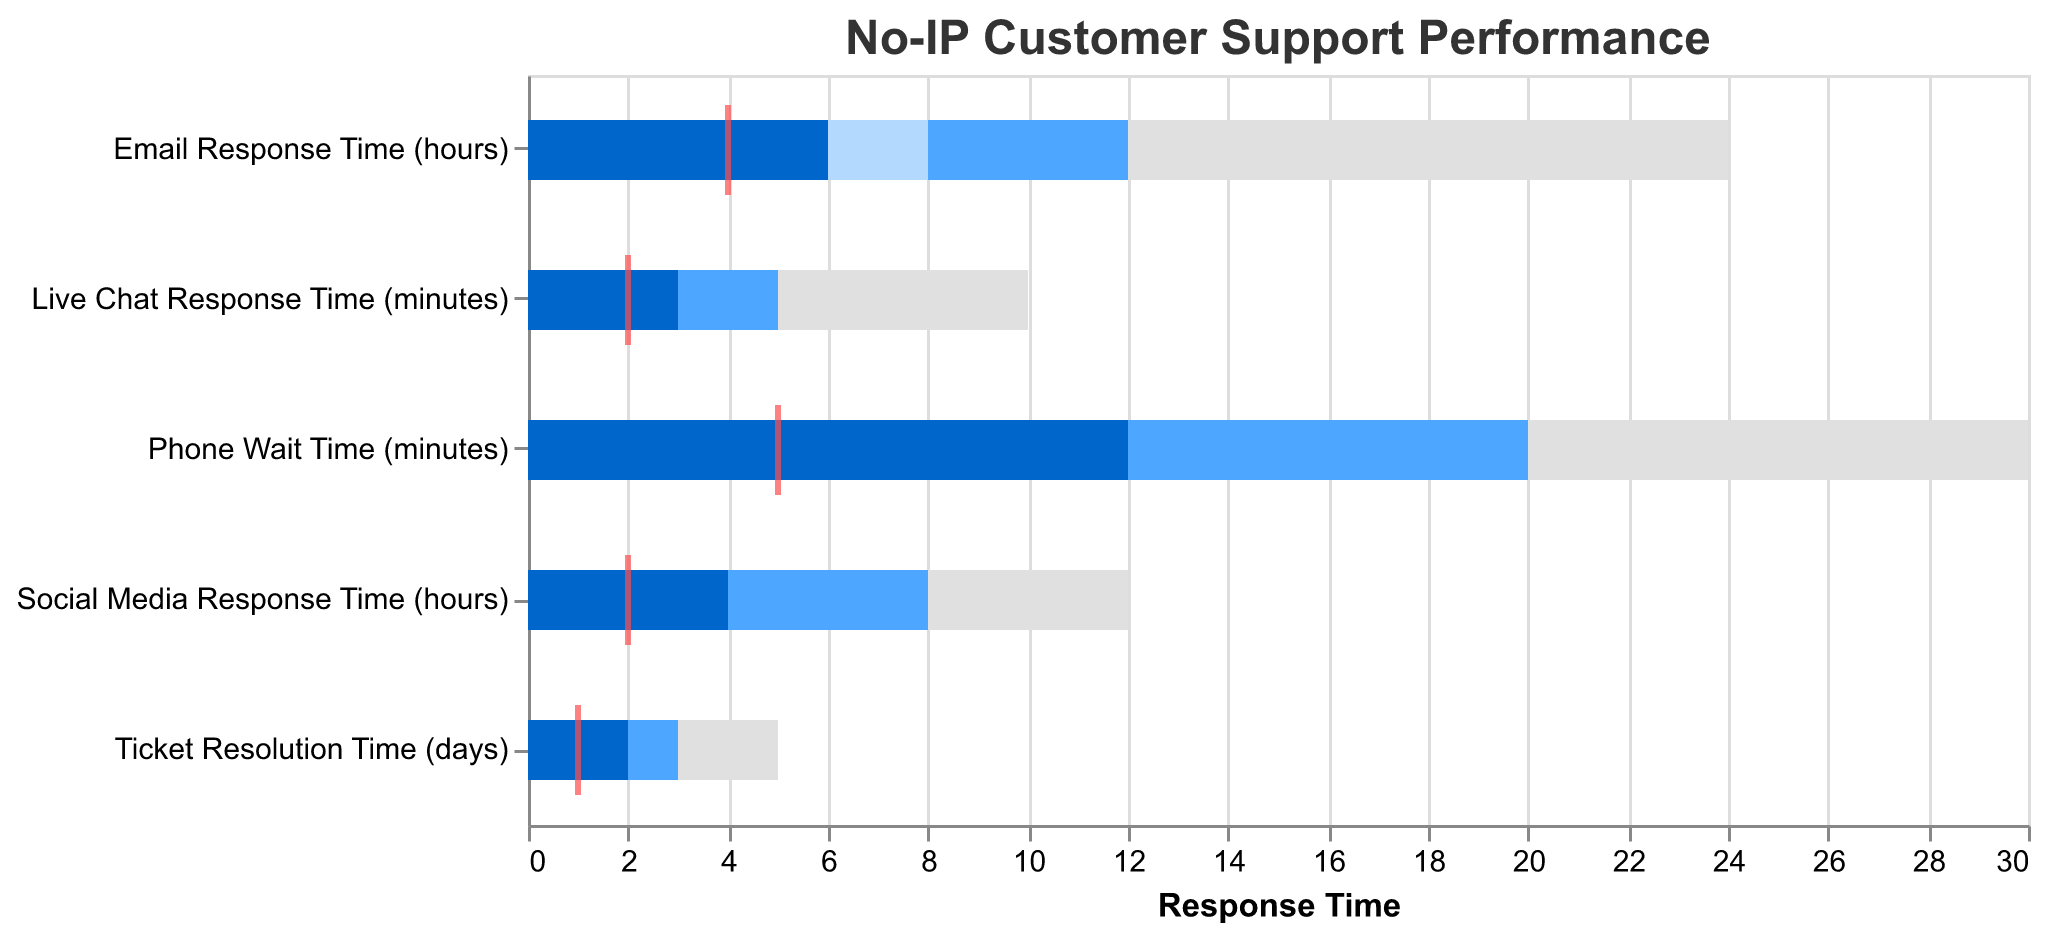What's the title of the chart? The title of the chart is usually displayed at the top. In this case, it's "No-IP Customer Support Performance".
Answer: No-IP Customer Support Performance Which response time category has the highest actual value? To find this, look at the actual values across all categories. The highest actual value is for "Phone Wait Time (minutes)" with 12 minutes.
Answer: Phone Wait Time (minutes) Is the actual "Ticket Resolution Time (days)" within the "Excellent" range? The "Excellent" range for "Ticket Resolution Time (days)" is 1 day. The actual value is 2 days, which is not within the "Excellent" range.
Answer: No Which categories have actual values that meet or beat their target? Compare the "Actual" values to their corresponding "Target" values. Only "Ticket Resolution Time (days)" (2 vs 1) does not meet or beat the target. Others exceed their targets.
Answer: None What is the difference between the actual and target values for "Email Response Time (hours)"? Subtract the target value (4 hours) from the actual value (6 hours) for "Email Response Time (hours)". 6 - 4 = 2 hours.
Answer: 2 hours Compare the "Live Chat Response Time (minutes)" to the industry standard's "Good" range. Does it meet the "Good" range? The "Good" range for "Live Chat Response Time (minutes)" is up to 3 minutes. The actual value is 3 minutes, which meets the "Good" range.
Answer: Yes Which category has the closest actual value to its target? By comparing the differences between actual and target values across all categories, "Email Response Time" has a difference of 2 hours (6 vs 4) which is closer than the rest.
Answer: Email Response Time (hours) Are any categories' actual values within the "Bad" range? The "Bad" range values for "Bad" are higher than those for "Actual", so you can determine. No categories have actual values within the "Bad" range.
Answer: No What is the average of all the target values depicted? Sum the target values for each category and then divide by the number of categories: (4+5+2+1+2)/5 = 14/5 = 2.8
Answer: 2.8 Which category has the lowest actual response time? From all categories, the "Live Chat Response Time (minutes)" has the lowest actual response time with 3 minutes.
Answer: Live Chat Response Time (minutes) 